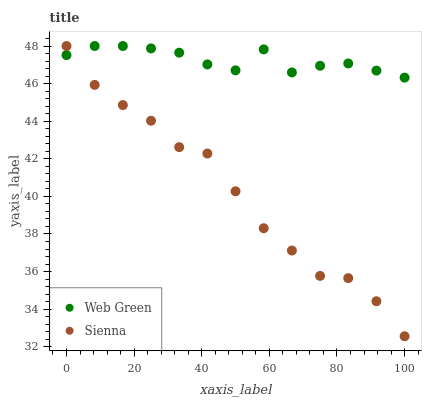Does Sienna have the minimum area under the curve?
Answer yes or no. Yes. Does Web Green have the maximum area under the curve?
Answer yes or no. Yes. Does Web Green have the minimum area under the curve?
Answer yes or no. No. Is Web Green the smoothest?
Answer yes or no. Yes. Is Sienna the roughest?
Answer yes or no. Yes. Is Web Green the roughest?
Answer yes or no. No. Does Sienna have the lowest value?
Answer yes or no. Yes. Does Web Green have the lowest value?
Answer yes or no. No. Does Web Green have the highest value?
Answer yes or no. Yes. Does Sienna intersect Web Green?
Answer yes or no. Yes. Is Sienna less than Web Green?
Answer yes or no. No. Is Sienna greater than Web Green?
Answer yes or no. No. 